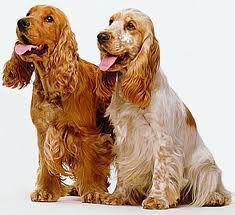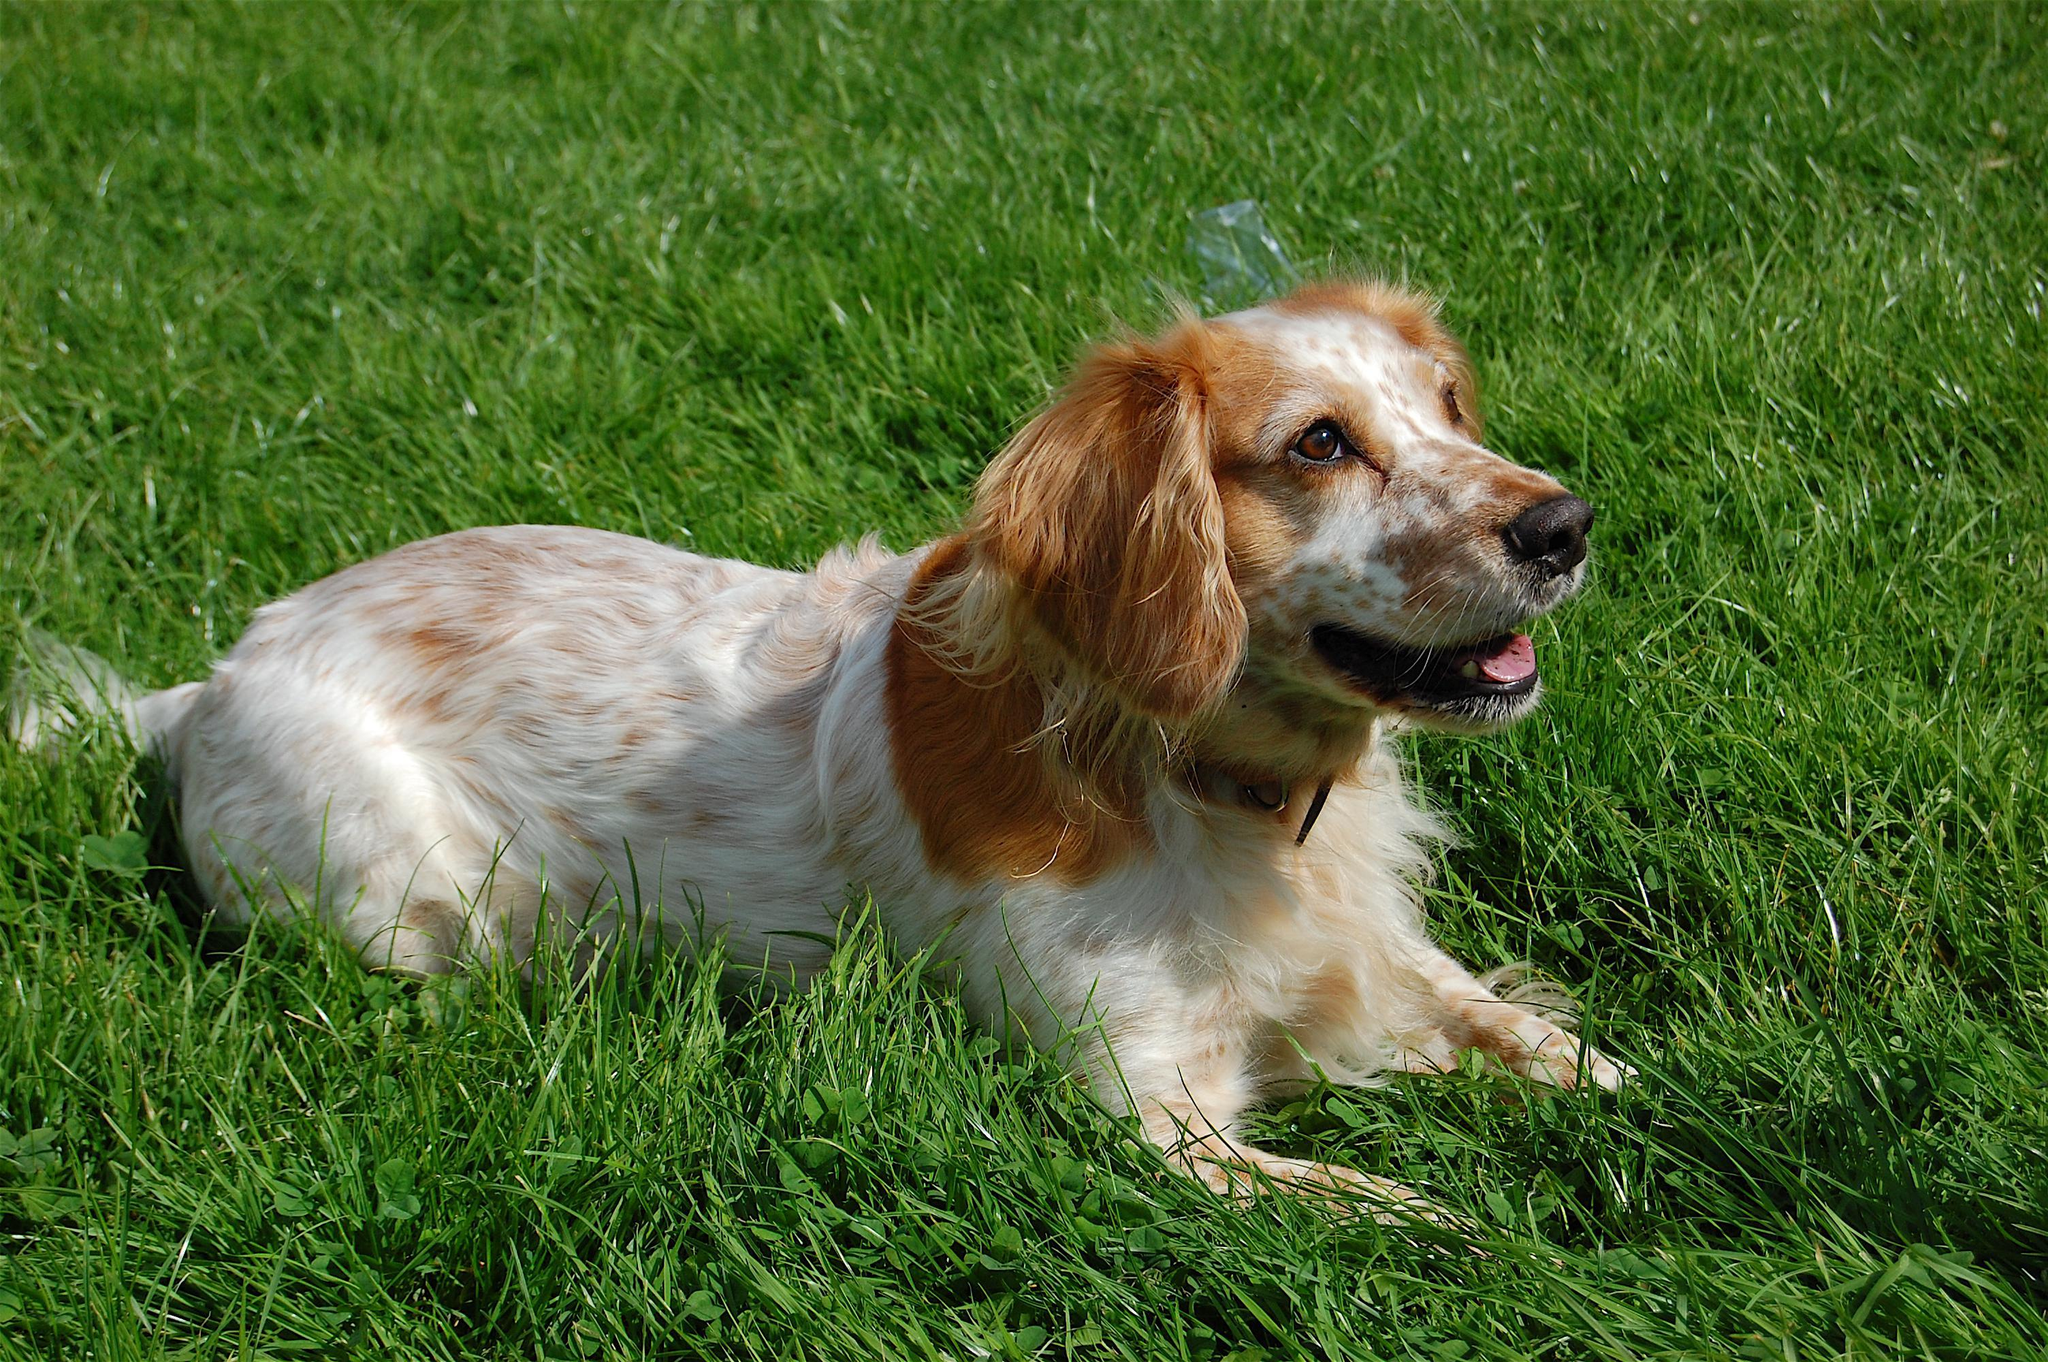The first image is the image on the left, the second image is the image on the right. Assess this claim about the two images: "At least one of the images shows a Cocker Spaniel with their tongue out.". Correct or not? Answer yes or no. Yes. The first image is the image on the left, the second image is the image on the right. Evaluate the accuracy of this statement regarding the images: "The combined images include one dog reclining with front paws extended and one dog with red-orange fur sitting upright.". Is it true? Answer yes or no. Yes. 